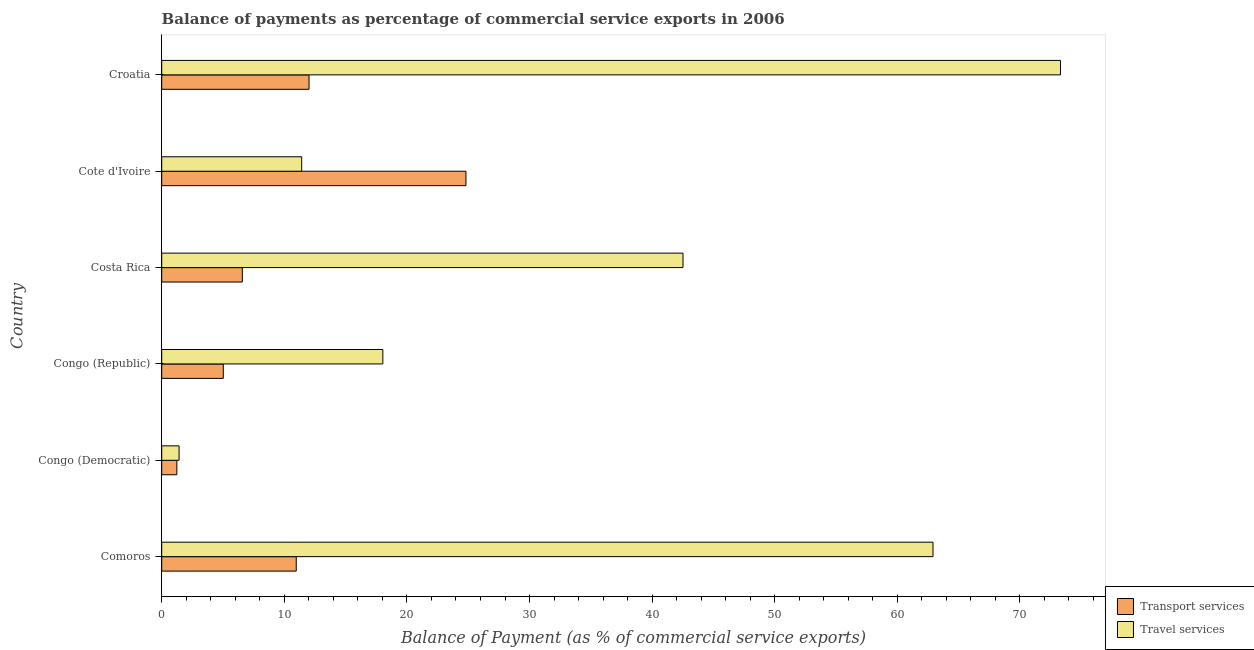How many groups of bars are there?
Ensure brevity in your answer.  6. How many bars are there on the 1st tick from the top?
Your answer should be very brief. 2. How many bars are there on the 3rd tick from the bottom?
Your response must be concise. 2. What is the label of the 4th group of bars from the top?
Ensure brevity in your answer.  Congo (Republic). What is the balance of payments of travel services in Costa Rica?
Offer a very short reply. 42.52. Across all countries, what is the maximum balance of payments of transport services?
Your answer should be very brief. 24.81. Across all countries, what is the minimum balance of payments of transport services?
Offer a very short reply. 1.23. In which country was the balance of payments of travel services maximum?
Provide a short and direct response. Croatia. In which country was the balance of payments of travel services minimum?
Offer a very short reply. Congo (Democratic). What is the total balance of payments of transport services in the graph?
Ensure brevity in your answer.  60.63. What is the difference between the balance of payments of transport services in Congo (Republic) and that in Costa Rica?
Your answer should be very brief. -1.55. What is the difference between the balance of payments of travel services in Comoros and the balance of payments of transport services in Congo (Republic)?
Give a very brief answer. 57.89. What is the average balance of payments of transport services per country?
Offer a terse response. 10.11. What is the difference between the balance of payments of travel services and balance of payments of transport services in Croatia?
Your answer should be very brief. 61.29. What is the ratio of the balance of payments of travel services in Costa Rica to that in Cote d'Ivoire?
Give a very brief answer. 3.72. Is the balance of payments of travel services in Comoros less than that in Costa Rica?
Keep it short and to the point. No. Is the difference between the balance of payments of travel services in Costa Rica and Cote d'Ivoire greater than the difference between the balance of payments of transport services in Costa Rica and Cote d'Ivoire?
Give a very brief answer. Yes. What is the difference between the highest and the second highest balance of payments of travel services?
Keep it short and to the point. 10.4. What is the difference between the highest and the lowest balance of payments of travel services?
Provide a short and direct response. 71.89. In how many countries, is the balance of payments of travel services greater than the average balance of payments of travel services taken over all countries?
Your answer should be compact. 3. What does the 1st bar from the top in Cote d'Ivoire represents?
Keep it short and to the point. Travel services. What does the 2nd bar from the bottom in Congo (Democratic) represents?
Provide a short and direct response. Travel services. Are all the bars in the graph horizontal?
Make the answer very short. Yes. How many countries are there in the graph?
Provide a succinct answer. 6. Are the values on the major ticks of X-axis written in scientific E-notation?
Make the answer very short. No. Does the graph contain any zero values?
Your answer should be very brief. No. How many legend labels are there?
Keep it short and to the point. 2. How are the legend labels stacked?
Give a very brief answer. Vertical. What is the title of the graph?
Offer a very short reply. Balance of payments as percentage of commercial service exports in 2006. What is the label or title of the X-axis?
Your answer should be compact. Balance of Payment (as % of commercial service exports). What is the label or title of the Y-axis?
Ensure brevity in your answer.  Country. What is the Balance of Payment (as % of commercial service exports) in Transport services in Comoros?
Your answer should be compact. 10.97. What is the Balance of Payment (as % of commercial service exports) of Travel services in Comoros?
Keep it short and to the point. 62.91. What is the Balance of Payment (as % of commercial service exports) in Transport services in Congo (Democratic)?
Offer a very short reply. 1.23. What is the Balance of Payment (as % of commercial service exports) in Travel services in Congo (Democratic)?
Provide a short and direct response. 1.42. What is the Balance of Payment (as % of commercial service exports) of Transport services in Congo (Republic)?
Your answer should be very brief. 5.02. What is the Balance of Payment (as % of commercial service exports) of Travel services in Congo (Republic)?
Offer a terse response. 18.04. What is the Balance of Payment (as % of commercial service exports) of Transport services in Costa Rica?
Your response must be concise. 6.57. What is the Balance of Payment (as % of commercial service exports) in Travel services in Costa Rica?
Your answer should be compact. 42.52. What is the Balance of Payment (as % of commercial service exports) of Transport services in Cote d'Ivoire?
Give a very brief answer. 24.81. What is the Balance of Payment (as % of commercial service exports) of Travel services in Cote d'Ivoire?
Keep it short and to the point. 11.42. What is the Balance of Payment (as % of commercial service exports) of Transport services in Croatia?
Provide a short and direct response. 12.02. What is the Balance of Payment (as % of commercial service exports) of Travel services in Croatia?
Your answer should be compact. 73.31. Across all countries, what is the maximum Balance of Payment (as % of commercial service exports) of Transport services?
Keep it short and to the point. 24.81. Across all countries, what is the maximum Balance of Payment (as % of commercial service exports) in Travel services?
Keep it short and to the point. 73.31. Across all countries, what is the minimum Balance of Payment (as % of commercial service exports) in Transport services?
Your answer should be compact. 1.23. Across all countries, what is the minimum Balance of Payment (as % of commercial service exports) of Travel services?
Ensure brevity in your answer.  1.42. What is the total Balance of Payment (as % of commercial service exports) in Transport services in the graph?
Your answer should be compact. 60.63. What is the total Balance of Payment (as % of commercial service exports) in Travel services in the graph?
Your answer should be very brief. 209.61. What is the difference between the Balance of Payment (as % of commercial service exports) of Transport services in Comoros and that in Congo (Democratic)?
Offer a very short reply. 9.74. What is the difference between the Balance of Payment (as % of commercial service exports) of Travel services in Comoros and that in Congo (Democratic)?
Offer a very short reply. 61.49. What is the difference between the Balance of Payment (as % of commercial service exports) of Transport services in Comoros and that in Congo (Republic)?
Ensure brevity in your answer.  5.95. What is the difference between the Balance of Payment (as % of commercial service exports) in Travel services in Comoros and that in Congo (Republic)?
Your response must be concise. 44.87. What is the difference between the Balance of Payment (as % of commercial service exports) of Transport services in Comoros and that in Costa Rica?
Keep it short and to the point. 4.4. What is the difference between the Balance of Payment (as % of commercial service exports) in Travel services in Comoros and that in Costa Rica?
Offer a terse response. 20.39. What is the difference between the Balance of Payment (as % of commercial service exports) in Transport services in Comoros and that in Cote d'Ivoire?
Offer a terse response. -13.84. What is the difference between the Balance of Payment (as % of commercial service exports) of Travel services in Comoros and that in Cote d'Ivoire?
Ensure brevity in your answer.  51.49. What is the difference between the Balance of Payment (as % of commercial service exports) of Transport services in Comoros and that in Croatia?
Provide a succinct answer. -1.04. What is the difference between the Balance of Payment (as % of commercial service exports) in Travel services in Comoros and that in Croatia?
Offer a very short reply. -10.4. What is the difference between the Balance of Payment (as % of commercial service exports) in Transport services in Congo (Democratic) and that in Congo (Republic)?
Give a very brief answer. -3.79. What is the difference between the Balance of Payment (as % of commercial service exports) of Travel services in Congo (Democratic) and that in Congo (Republic)?
Make the answer very short. -16.62. What is the difference between the Balance of Payment (as % of commercial service exports) in Transport services in Congo (Democratic) and that in Costa Rica?
Your answer should be very brief. -5.34. What is the difference between the Balance of Payment (as % of commercial service exports) of Travel services in Congo (Democratic) and that in Costa Rica?
Ensure brevity in your answer.  -41.1. What is the difference between the Balance of Payment (as % of commercial service exports) in Transport services in Congo (Democratic) and that in Cote d'Ivoire?
Provide a succinct answer. -23.58. What is the difference between the Balance of Payment (as % of commercial service exports) of Travel services in Congo (Democratic) and that in Cote d'Ivoire?
Provide a succinct answer. -10. What is the difference between the Balance of Payment (as % of commercial service exports) in Transport services in Congo (Democratic) and that in Croatia?
Provide a succinct answer. -10.78. What is the difference between the Balance of Payment (as % of commercial service exports) in Travel services in Congo (Democratic) and that in Croatia?
Your response must be concise. -71.89. What is the difference between the Balance of Payment (as % of commercial service exports) of Transport services in Congo (Republic) and that in Costa Rica?
Offer a very short reply. -1.55. What is the difference between the Balance of Payment (as % of commercial service exports) in Travel services in Congo (Republic) and that in Costa Rica?
Ensure brevity in your answer.  -24.48. What is the difference between the Balance of Payment (as % of commercial service exports) in Transport services in Congo (Republic) and that in Cote d'Ivoire?
Your answer should be very brief. -19.79. What is the difference between the Balance of Payment (as % of commercial service exports) of Travel services in Congo (Republic) and that in Cote d'Ivoire?
Your answer should be compact. 6.62. What is the difference between the Balance of Payment (as % of commercial service exports) of Transport services in Congo (Republic) and that in Croatia?
Your response must be concise. -6.99. What is the difference between the Balance of Payment (as % of commercial service exports) of Travel services in Congo (Republic) and that in Croatia?
Offer a very short reply. -55.27. What is the difference between the Balance of Payment (as % of commercial service exports) in Transport services in Costa Rica and that in Cote d'Ivoire?
Your response must be concise. -18.24. What is the difference between the Balance of Payment (as % of commercial service exports) in Travel services in Costa Rica and that in Cote d'Ivoire?
Keep it short and to the point. 31.1. What is the difference between the Balance of Payment (as % of commercial service exports) of Transport services in Costa Rica and that in Croatia?
Offer a terse response. -5.44. What is the difference between the Balance of Payment (as % of commercial service exports) of Travel services in Costa Rica and that in Croatia?
Give a very brief answer. -30.79. What is the difference between the Balance of Payment (as % of commercial service exports) in Transport services in Cote d'Ivoire and that in Croatia?
Make the answer very short. 12.8. What is the difference between the Balance of Payment (as % of commercial service exports) of Travel services in Cote d'Ivoire and that in Croatia?
Your response must be concise. -61.89. What is the difference between the Balance of Payment (as % of commercial service exports) in Transport services in Comoros and the Balance of Payment (as % of commercial service exports) in Travel services in Congo (Democratic)?
Your answer should be compact. 9.56. What is the difference between the Balance of Payment (as % of commercial service exports) in Transport services in Comoros and the Balance of Payment (as % of commercial service exports) in Travel services in Congo (Republic)?
Your answer should be very brief. -7.06. What is the difference between the Balance of Payment (as % of commercial service exports) in Transport services in Comoros and the Balance of Payment (as % of commercial service exports) in Travel services in Costa Rica?
Make the answer very short. -31.55. What is the difference between the Balance of Payment (as % of commercial service exports) in Transport services in Comoros and the Balance of Payment (as % of commercial service exports) in Travel services in Cote d'Ivoire?
Provide a short and direct response. -0.45. What is the difference between the Balance of Payment (as % of commercial service exports) in Transport services in Comoros and the Balance of Payment (as % of commercial service exports) in Travel services in Croatia?
Give a very brief answer. -62.34. What is the difference between the Balance of Payment (as % of commercial service exports) of Transport services in Congo (Democratic) and the Balance of Payment (as % of commercial service exports) of Travel services in Congo (Republic)?
Your answer should be compact. -16.8. What is the difference between the Balance of Payment (as % of commercial service exports) in Transport services in Congo (Democratic) and the Balance of Payment (as % of commercial service exports) in Travel services in Costa Rica?
Offer a terse response. -41.29. What is the difference between the Balance of Payment (as % of commercial service exports) of Transport services in Congo (Democratic) and the Balance of Payment (as % of commercial service exports) of Travel services in Cote d'Ivoire?
Make the answer very short. -10.18. What is the difference between the Balance of Payment (as % of commercial service exports) of Transport services in Congo (Democratic) and the Balance of Payment (as % of commercial service exports) of Travel services in Croatia?
Give a very brief answer. -72.08. What is the difference between the Balance of Payment (as % of commercial service exports) of Transport services in Congo (Republic) and the Balance of Payment (as % of commercial service exports) of Travel services in Costa Rica?
Give a very brief answer. -37.5. What is the difference between the Balance of Payment (as % of commercial service exports) in Transport services in Congo (Republic) and the Balance of Payment (as % of commercial service exports) in Travel services in Cote d'Ivoire?
Keep it short and to the point. -6.39. What is the difference between the Balance of Payment (as % of commercial service exports) in Transport services in Congo (Republic) and the Balance of Payment (as % of commercial service exports) in Travel services in Croatia?
Give a very brief answer. -68.29. What is the difference between the Balance of Payment (as % of commercial service exports) of Transport services in Costa Rica and the Balance of Payment (as % of commercial service exports) of Travel services in Cote d'Ivoire?
Make the answer very short. -4.84. What is the difference between the Balance of Payment (as % of commercial service exports) of Transport services in Costa Rica and the Balance of Payment (as % of commercial service exports) of Travel services in Croatia?
Your answer should be very brief. -66.73. What is the difference between the Balance of Payment (as % of commercial service exports) of Transport services in Cote d'Ivoire and the Balance of Payment (as % of commercial service exports) of Travel services in Croatia?
Offer a terse response. -48.49. What is the average Balance of Payment (as % of commercial service exports) in Transport services per country?
Ensure brevity in your answer.  10.11. What is the average Balance of Payment (as % of commercial service exports) of Travel services per country?
Give a very brief answer. 34.93. What is the difference between the Balance of Payment (as % of commercial service exports) in Transport services and Balance of Payment (as % of commercial service exports) in Travel services in Comoros?
Offer a very short reply. -51.94. What is the difference between the Balance of Payment (as % of commercial service exports) in Transport services and Balance of Payment (as % of commercial service exports) in Travel services in Congo (Democratic)?
Offer a terse response. -0.18. What is the difference between the Balance of Payment (as % of commercial service exports) of Transport services and Balance of Payment (as % of commercial service exports) of Travel services in Congo (Republic)?
Provide a succinct answer. -13.01. What is the difference between the Balance of Payment (as % of commercial service exports) in Transport services and Balance of Payment (as % of commercial service exports) in Travel services in Costa Rica?
Give a very brief answer. -35.94. What is the difference between the Balance of Payment (as % of commercial service exports) in Transport services and Balance of Payment (as % of commercial service exports) in Travel services in Cote d'Ivoire?
Your answer should be compact. 13.4. What is the difference between the Balance of Payment (as % of commercial service exports) in Transport services and Balance of Payment (as % of commercial service exports) in Travel services in Croatia?
Provide a short and direct response. -61.29. What is the ratio of the Balance of Payment (as % of commercial service exports) in Transport services in Comoros to that in Congo (Democratic)?
Offer a terse response. 8.89. What is the ratio of the Balance of Payment (as % of commercial service exports) in Travel services in Comoros to that in Congo (Democratic)?
Your response must be concise. 44.4. What is the ratio of the Balance of Payment (as % of commercial service exports) in Transport services in Comoros to that in Congo (Republic)?
Make the answer very short. 2.18. What is the ratio of the Balance of Payment (as % of commercial service exports) in Travel services in Comoros to that in Congo (Republic)?
Keep it short and to the point. 3.49. What is the ratio of the Balance of Payment (as % of commercial service exports) in Transport services in Comoros to that in Costa Rica?
Ensure brevity in your answer.  1.67. What is the ratio of the Balance of Payment (as % of commercial service exports) of Travel services in Comoros to that in Costa Rica?
Give a very brief answer. 1.48. What is the ratio of the Balance of Payment (as % of commercial service exports) in Transport services in Comoros to that in Cote d'Ivoire?
Your answer should be compact. 0.44. What is the ratio of the Balance of Payment (as % of commercial service exports) of Travel services in Comoros to that in Cote d'Ivoire?
Ensure brevity in your answer.  5.51. What is the ratio of the Balance of Payment (as % of commercial service exports) in Transport services in Comoros to that in Croatia?
Your response must be concise. 0.91. What is the ratio of the Balance of Payment (as % of commercial service exports) of Travel services in Comoros to that in Croatia?
Your answer should be compact. 0.86. What is the ratio of the Balance of Payment (as % of commercial service exports) of Transport services in Congo (Democratic) to that in Congo (Republic)?
Offer a terse response. 0.25. What is the ratio of the Balance of Payment (as % of commercial service exports) in Travel services in Congo (Democratic) to that in Congo (Republic)?
Provide a short and direct response. 0.08. What is the ratio of the Balance of Payment (as % of commercial service exports) in Transport services in Congo (Democratic) to that in Costa Rica?
Offer a very short reply. 0.19. What is the ratio of the Balance of Payment (as % of commercial service exports) of Transport services in Congo (Democratic) to that in Cote d'Ivoire?
Offer a terse response. 0.05. What is the ratio of the Balance of Payment (as % of commercial service exports) of Travel services in Congo (Democratic) to that in Cote d'Ivoire?
Offer a terse response. 0.12. What is the ratio of the Balance of Payment (as % of commercial service exports) in Transport services in Congo (Democratic) to that in Croatia?
Ensure brevity in your answer.  0.1. What is the ratio of the Balance of Payment (as % of commercial service exports) in Travel services in Congo (Democratic) to that in Croatia?
Offer a terse response. 0.02. What is the ratio of the Balance of Payment (as % of commercial service exports) of Transport services in Congo (Republic) to that in Costa Rica?
Give a very brief answer. 0.76. What is the ratio of the Balance of Payment (as % of commercial service exports) of Travel services in Congo (Republic) to that in Costa Rica?
Ensure brevity in your answer.  0.42. What is the ratio of the Balance of Payment (as % of commercial service exports) of Transport services in Congo (Republic) to that in Cote d'Ivoire?
Provide a succinct answer. 0.2. What is the ratio of the Balance of Payment (as % of commercial service exports) in Travel services in Congo (Republic) to that in Cote d'Ivoire?
Give a very brief answer. 1.58. What is the ratio of the Balance of Payment (as % of commercial service exports) of Transport services in Congo (Republic) to that in Croatia?
Ensure brevity in your answer.  0.42. What is the ratio of the Balance of Payment (as % of commercial service exports) in Travel services in Congo (Republic) to that in Croatia?
Provide a succinct answer. 0.25. What is the ratio of the Balance of Payment (as % of commercial service exports) of Transport services in Costa Rica to that in Cote d'Ivoire?
Your response must be concise. 0.27. What is the ratio of the Balance of Payment (as % of commercial service exports) in Travel services in Costa Rica to that in Cote d'Ivoire?
Your answer should be very brief. 3.72. What is the ratio of the Balance of Payment (as % of commercial service exports) in Transport services in Costa Rica to that in Croatia?
Your answer should be very brief. 0.55. What is the ratio of the Balance of Payment (as % of commercial service exports) of Travel services in Costa Rica to that in Croatia?
Keep it short and to the point. 0.58. What is the ratio of the Balance of Payment (as % of commercial service exports) in Transport services in Cote d'Ivoire to that in Croatia?
Keep it short and to the point. 2.07. What is the ratio of the Balance of Payment (as % of commercial service exports) of Travel services in Cote d'Ivoire to that in Croatia?
Your answer should be compact. 0.16. What is the difference between the highest and the second highest Balance of Payment (as % of commercial service exports) of Transport services?
Offer a very short reply. 12.8. What is the difference between the highest and the second highest Balance of Payment (as % of commercial service exports) of Travel services?
Provide a succinct answer. 10.4. What is the difference between the highest and the lowest Balance of Payment (as % of commercial service exports) in Transport services?
Make the answer very short. 23.58. What is the difference between the highest and the lowest Balance of Payment (as % of commercial service exports) of Travel services?
Provide a succinct answer. 71.89. 